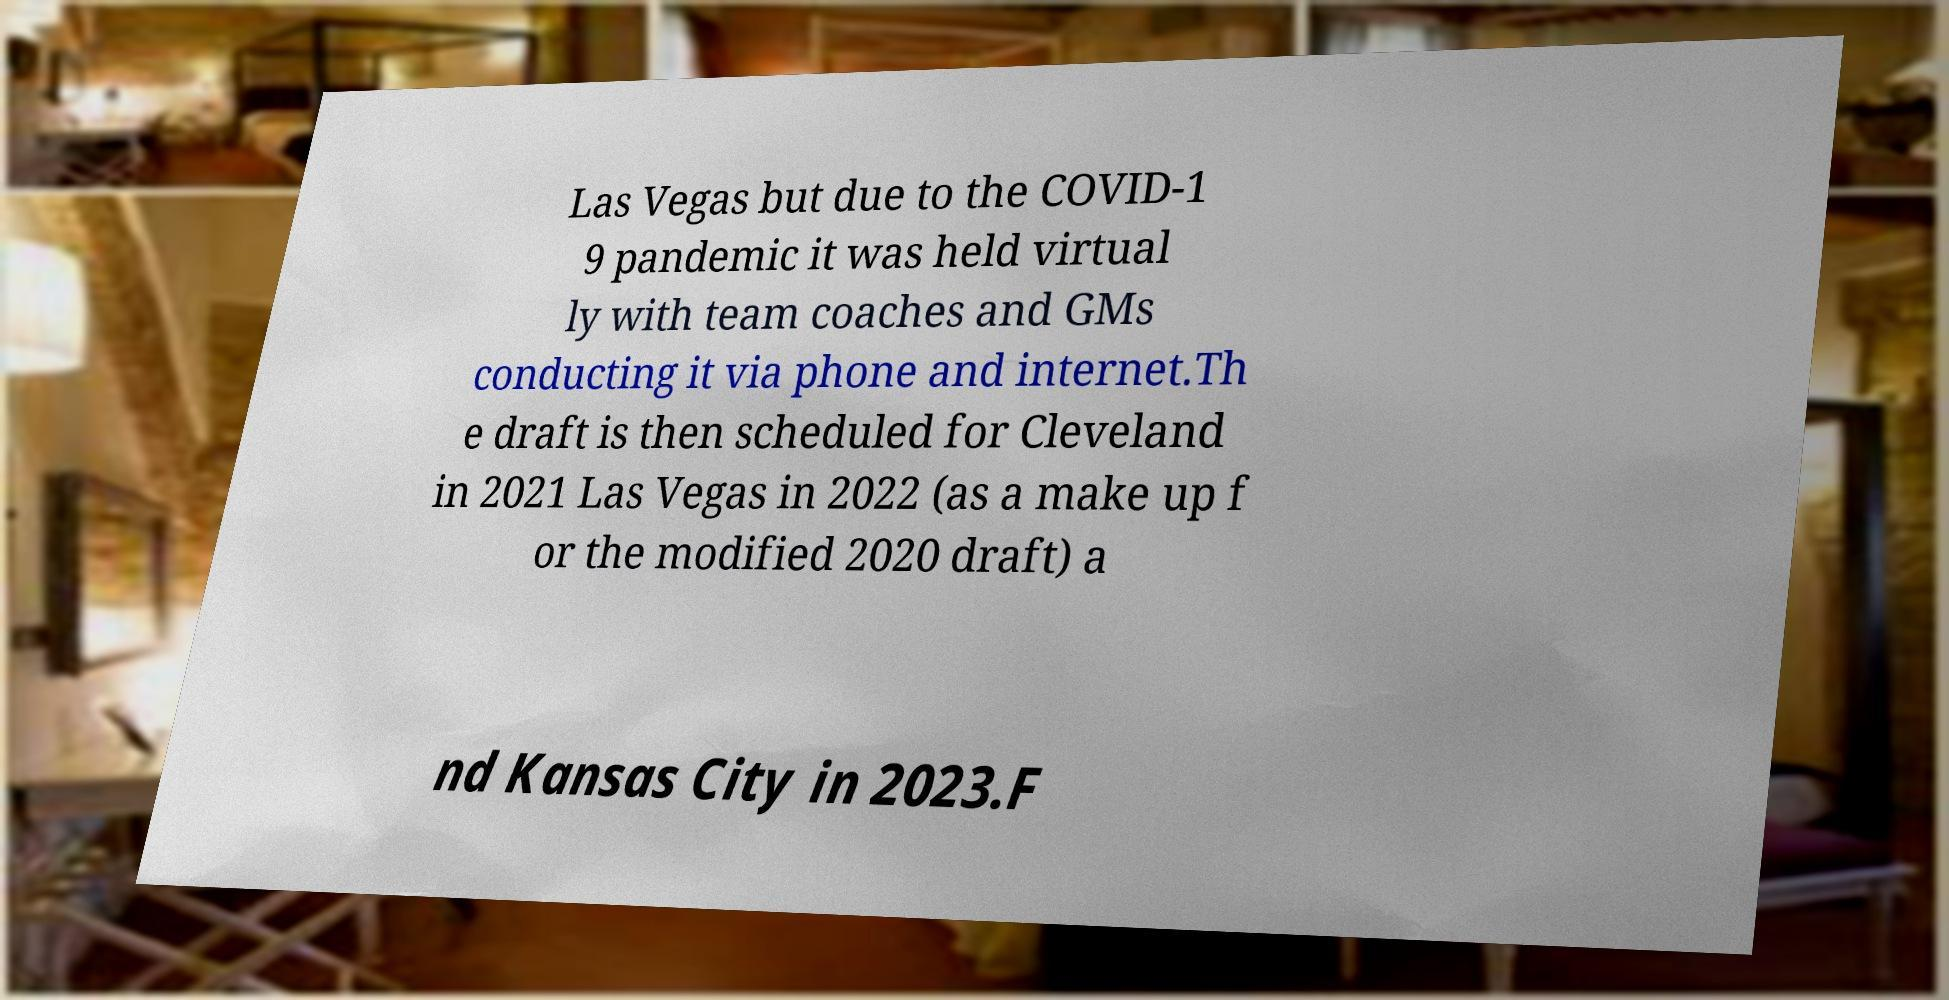What messages or text are displayed in this image? I need them in a readable, typed format. Las Vegas but due to the COVID-1 9 pandemic it was held virtual ly with team coaches and GMs conducting it via phone and internet.Th e draft is then scheduled for Cleveland in 2021 Las Vegas in 2022 (as a make up f or the modified 2020 draft) a nd Kansas City in 2023.F 